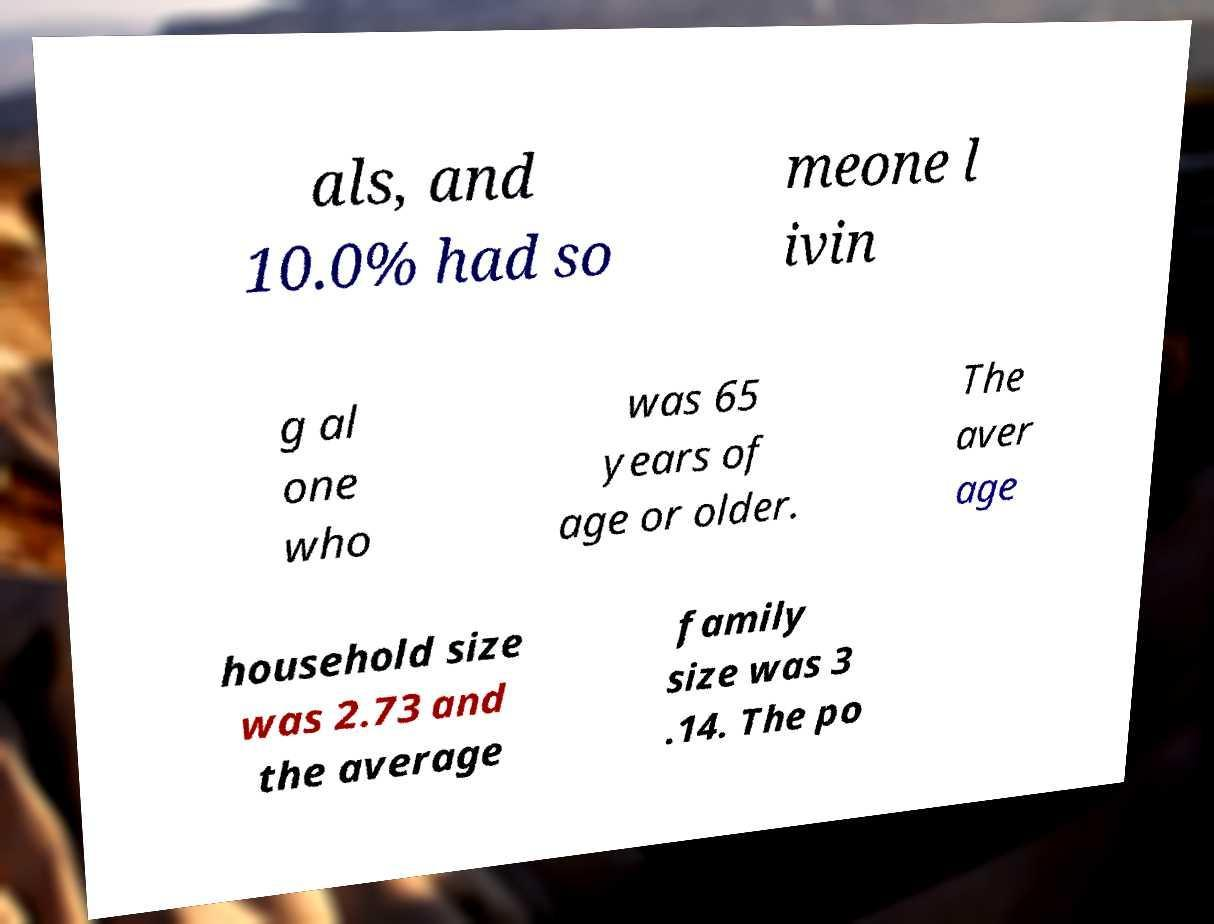Can you accurately transcribe the text from the provided image for me? als, and 10.0% had so meone l ivin g al one who was 65 years of age or older. The aver age household size was 2.73 and the average family size was 3 .14. The po 